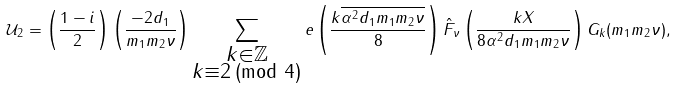Convert formula to latex. <formula><loc_0><loc_0><loc_500><loc_500>\mathcal { U } _ { 2 } = \left ( \frac { 1 - i } { 2 } \right ) \left ( \frac { - 2 d _ { 1 } } { m _ { 1 } m _ { 2 } \nu } \right ) \sum _ { \substack { k \in \mathbb { Z } \\ k \equiv 2 \, ( \text {mod } 4 ) } } e \left ( \frac { k \overline { \alpha ^ { 2 } d _ { 1 } m _ { 1 } m _ { 2 } \nu } } { 8 } \right ) \hat { F } _ { \nu } \left ( \frac { k X } { 8 \alpha ^ { 2 } d _ { 1 } m _ { 1 } m _ { 2 } \nu } \right ) G _ { k } ( m _ { 1 } m _ { 2 } \nu ) ,</formula> 